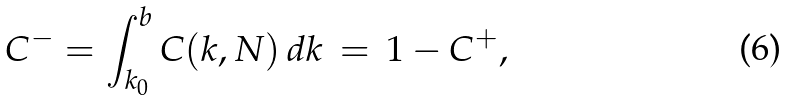Convert formula to latex. <formula><loc_0><loc_0><loc_500><loc_500>C ^ { - } = \int _ { k _ { 0 } } ^ { b } C ( k , N ) \, d k \, = \, 1 - C ^ { + } ,</formula> 